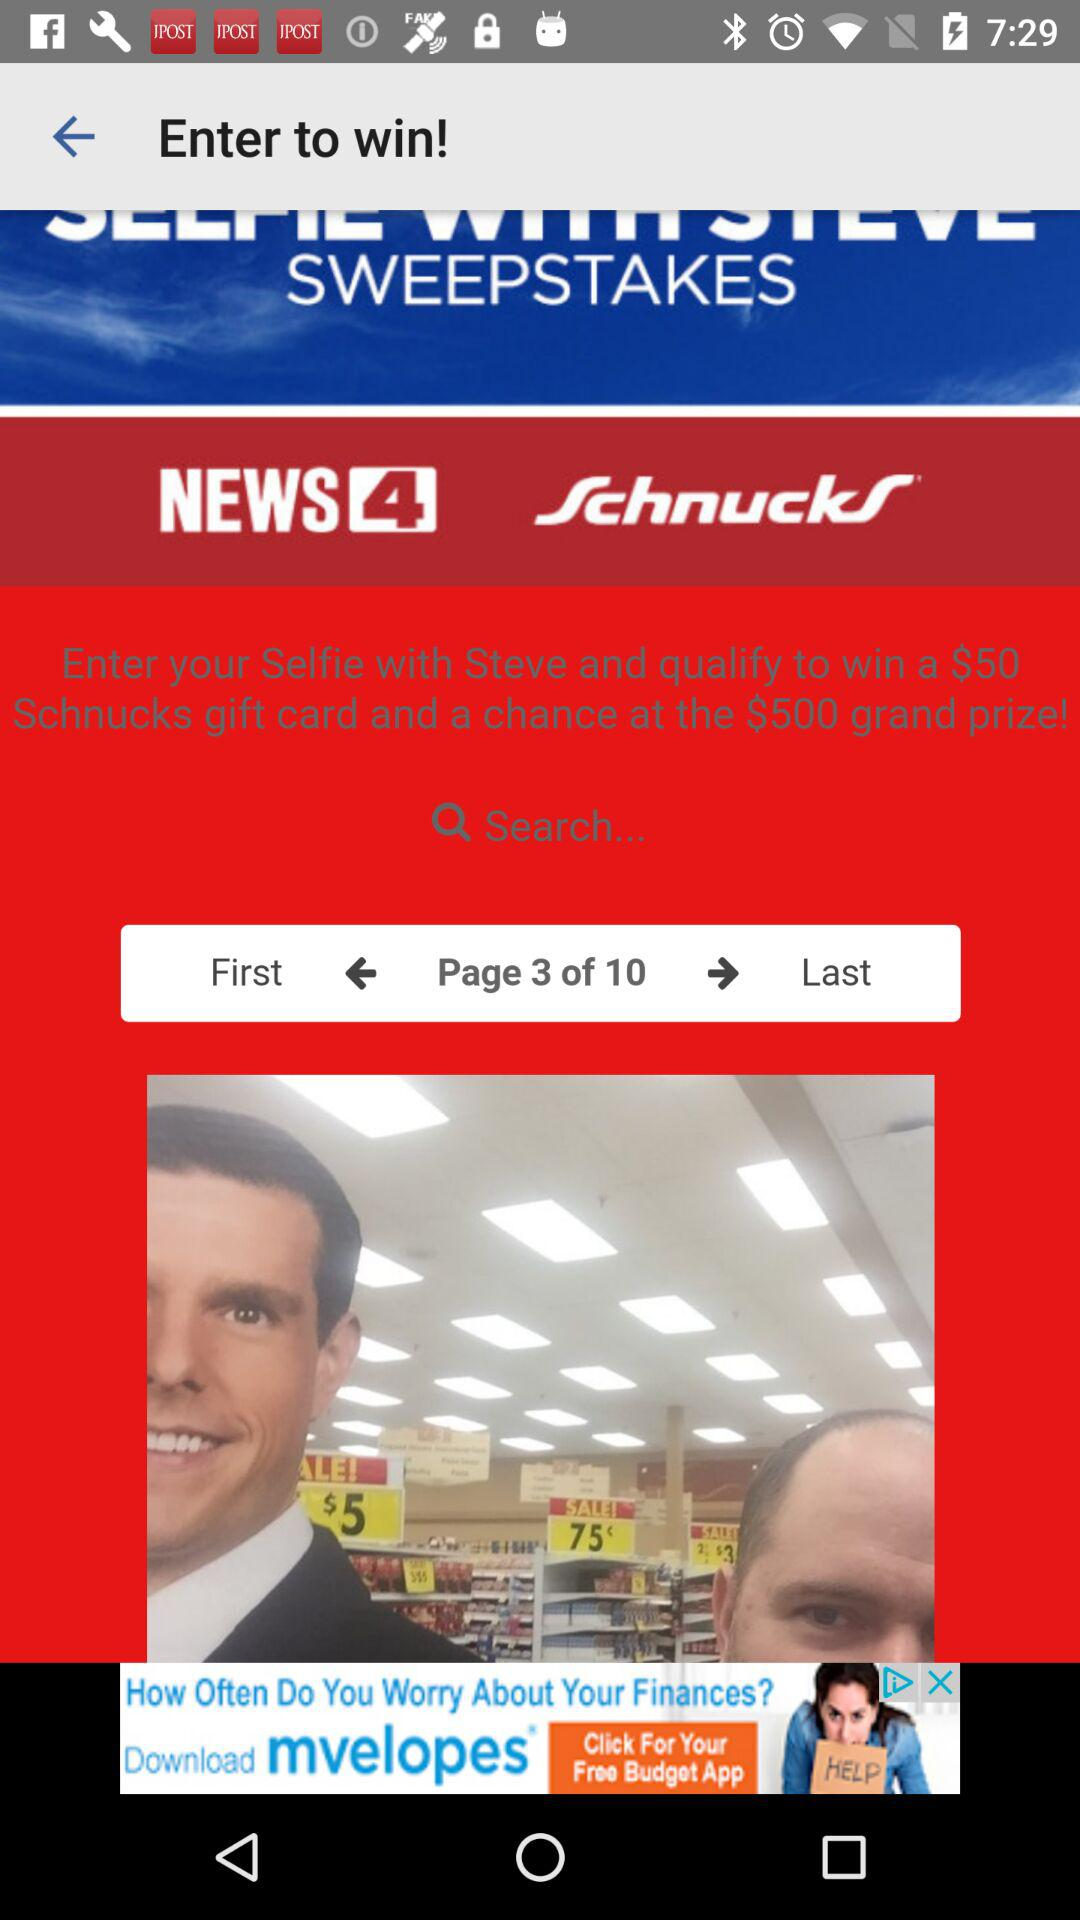How many pages are there in the sweepstakes?
Answer the question using a single word or phrase. 10 